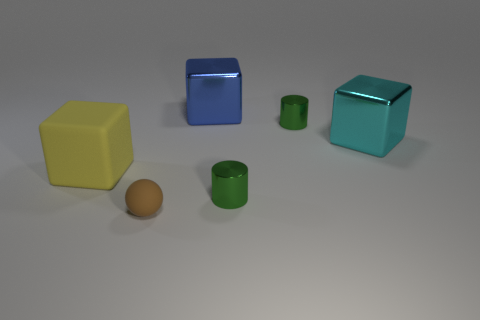Can you describe the shape of the objects in the background? Certainly! There are two cubic shapes with clearly defined edges and smooth surfaces suggesting a solid, 3-dimensional geometry. 